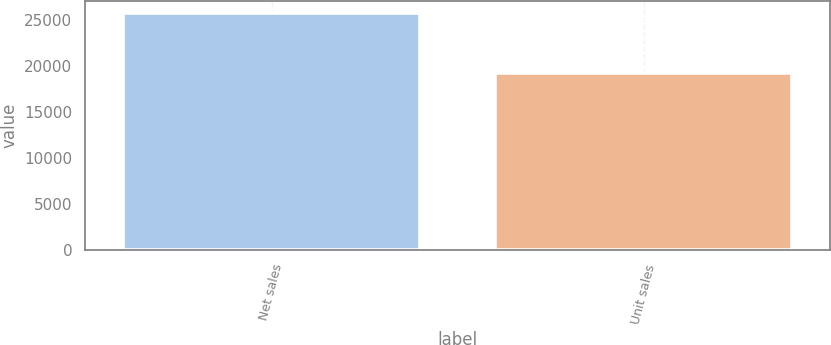Convert chart. <chart><loc_0><loc_0><loc_500><loc_500><bar_chart><fcel>Net sales<fcel>Unit sales<nl><fcel>25850<fcel>19251<nl></chart> 